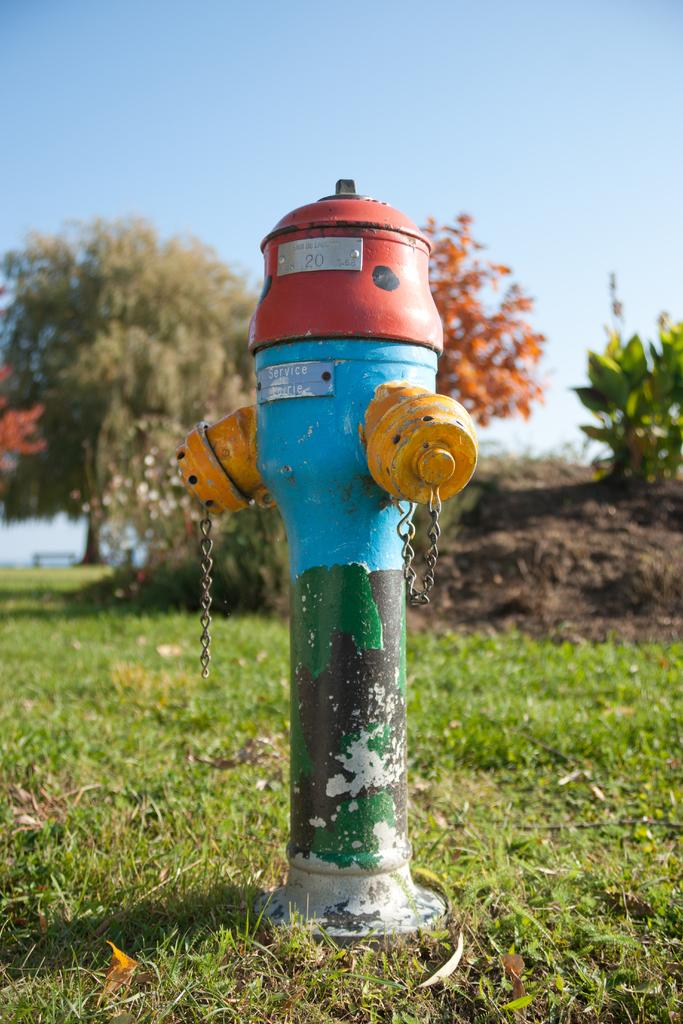<image>
Write a terse but informative summary of the picture. A fire hydrant that says Eau de something with the number twenty and below that, it says service. 